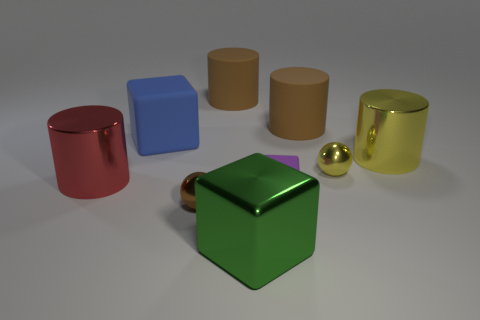There is a matte block that is behind the tiny purple matte cube on the right side of the blue rubber thing; how many large blue blocks are in front of it?
Offer a terse response. 0. How many brown objects are large rubber cylinders or rubber cubes?
Offer a very short reply. 2. What is the shape of the rubber object that is in front of the red metallic thing?
Your response must be concise. Cube. The other rubber block that is the same size as the green cube is what color?
Keep it short and to the point. Blue. Is the shape of the red thing the same as the brown matte thing that is on the left side of the large green metal thing?
Ensure brevity in your answer.  Yes. There is a block that is in front of the rubber object that is in front of the shiny cylinder behind the red metallic cylinder; what is its material?
Your answer should be compact. Metal. What number of tiny things are either purple rubber cubes or shiny spheres?
Offer a terse response. 3. How many other objects are the same size as the blue object?
Keep it short and to the point. 5. Does the big matte thing that is on the right side of the purple rubber block have the same shape as the purple object?
Offer a terse response. No. There is another tiny thing that is the same shape as the tiny brown metallic thing; what color is it?
Offer a very short reply. Yellow. 